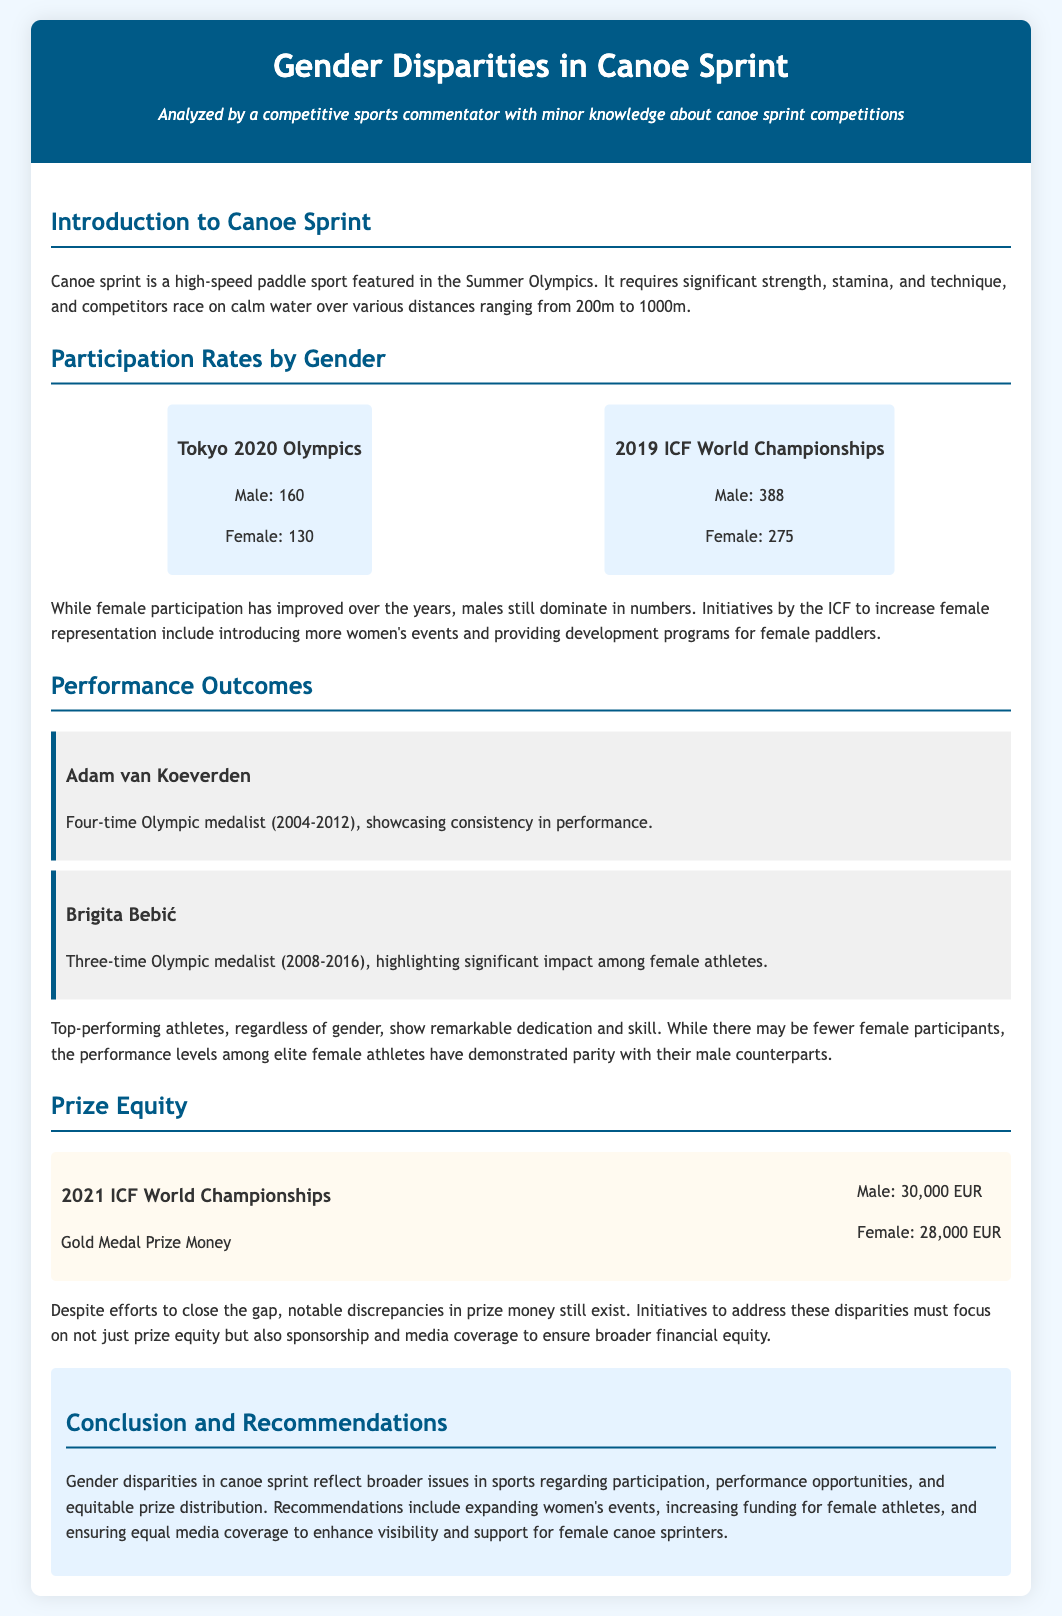What was the male participation rate at the Tokyo 2020 Olympics? The male participation rate was given as 160 in the document.
Answer: 160 How many female athletes participated in the 2019 ICF World Championships? The document states that female participation was 275.
Answer: 275 Who is a three-time Olympic medalist mentioned in the document? The document highlights Brigita Bebić as a three-time Olympic medalist.
Answer: Brigita Bebić What is the prize money for male gold medalists at the 2021 ICF World Championships? The document specifies the male gold medal prize money as 30,000 EUR.
Answer: 30,000 EUR What initiative is suggested to improve female participation in canoe sprint? The document recommends expanding women's events as an initiative.
Answer: Expanding women's events What did the conclusion suggest about media coverage? The conclusion states that equal media coverage is needed to enhance visibility for female athletes.
Answer: Equal media coverage How many medals did Adam van Koeverden win across Olympics? Adam van Koeverden is referred to as a four-time Olympic medalist in the document.
Answer: Four What is the prize money for female gold medalists at the 2021 ICF World Championships? The document indicates that the female gold medal prize money is 28,000 EUR.
Answer: 28,000 EUR What is one of the recommendations for addressing gender disparities in canoe sprint? The recommendations include increasing funding for female athletes, as mentioned in the document.
Answer: Increasing funding for female athletes 